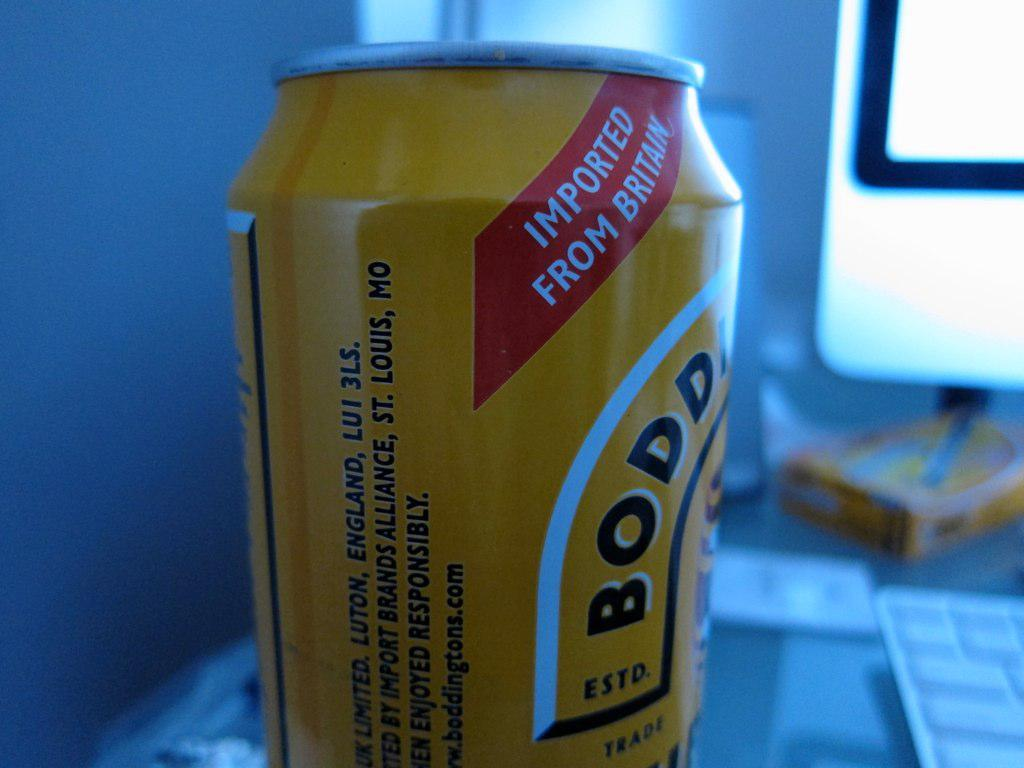What is the main object in the middle of the image? There is a yellow tin with a red label in the middle of the image. What can be seen on the tin? Something is written on the tin. What electronic devices are in the right corner of the image? There is a monitor and a keyboard in the right corner of the image. What is the texture of the crook in the image? There is no crook present in the image. How does the tongue interact with the yellow tin in the image? There is no tongue present in the image, and therefore no interaction can be observed. 